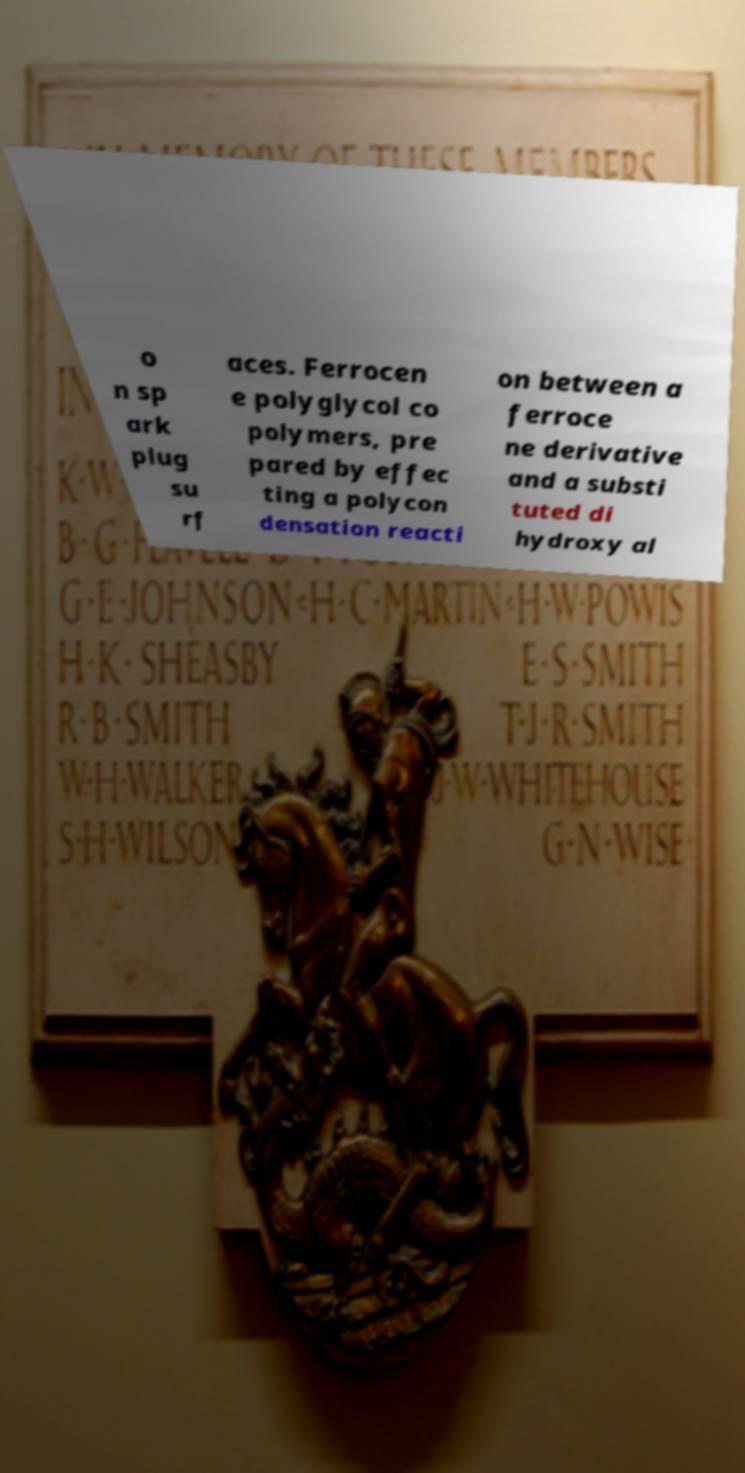Could you extract and type out the text from this image? o n sp ark plug su rf aces. Ferrocen e polyglycol co polymers, pre pared by effec ting a polycon densation reacti on between a ferroce ne derivative and a substi tuted di hydroxy al 